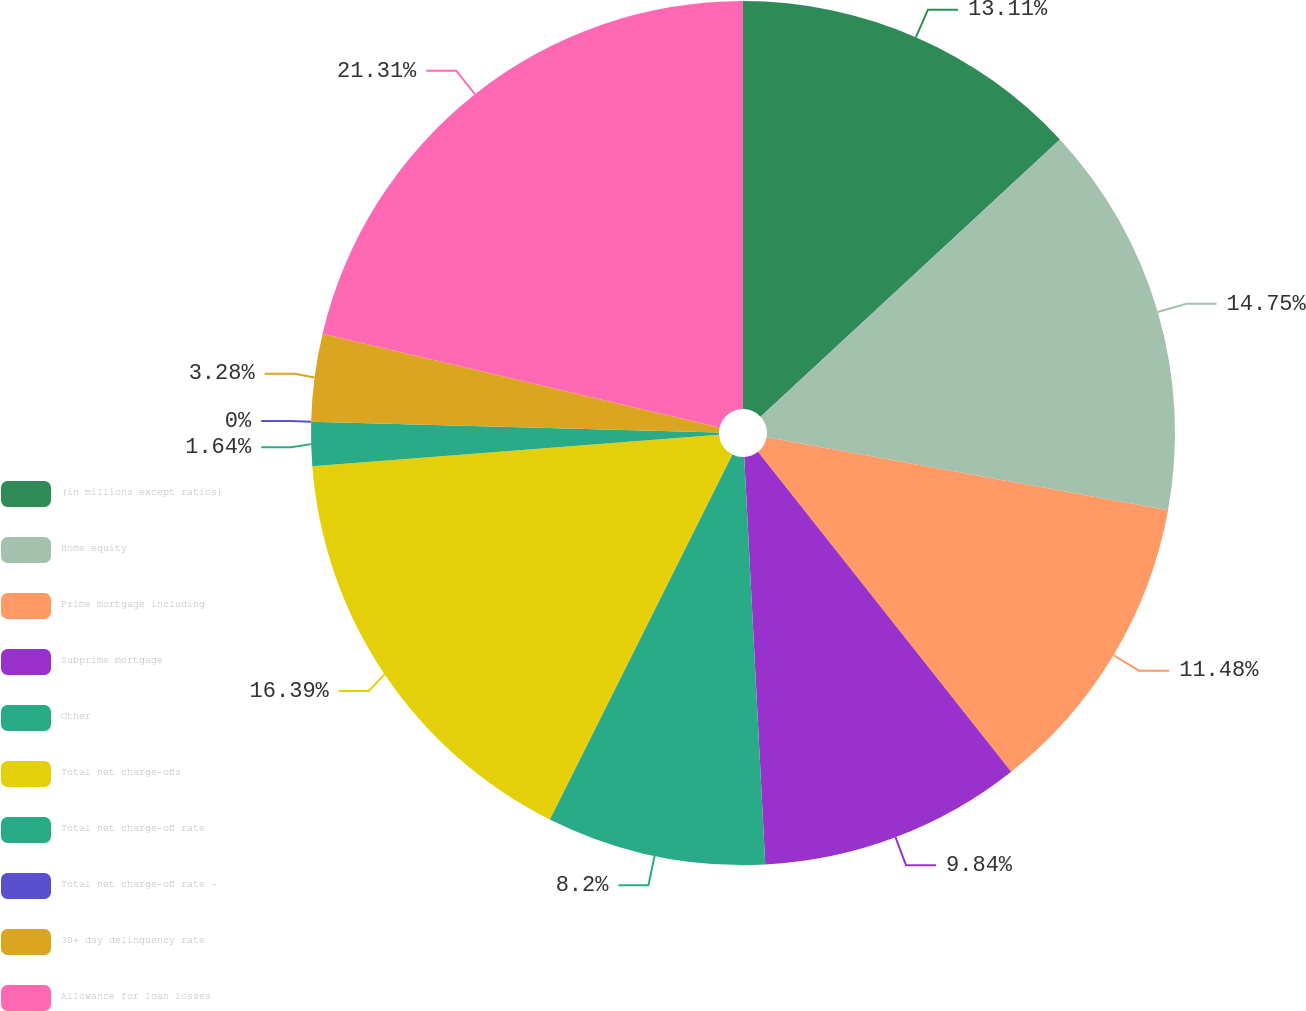Convert chart to OTSL. <chart><loc_0><loc_0><loc_500><loc_500><pie_chart><fcel>(in millions except ratios)<fcel>Home equity<fcel>Prime mortgage including<fcel>Subprime mortgage<fcel>Other<fcel>Total net charge-offs<fcel>Total net charge-off rate<fcel>Total net charge-off rate -<fcel>30+ day delinquency rate<fcel>Allowance for loan losses<nl><fcel>13.11%<fcel>14.75%<fcel>11.48%<fcel>9.84%<fcel>8.2%<fcel>16.39%<fcel>1.64%<fcel>0.0%<fcel>3.28%<fcel>21.31%<nl></chart> 